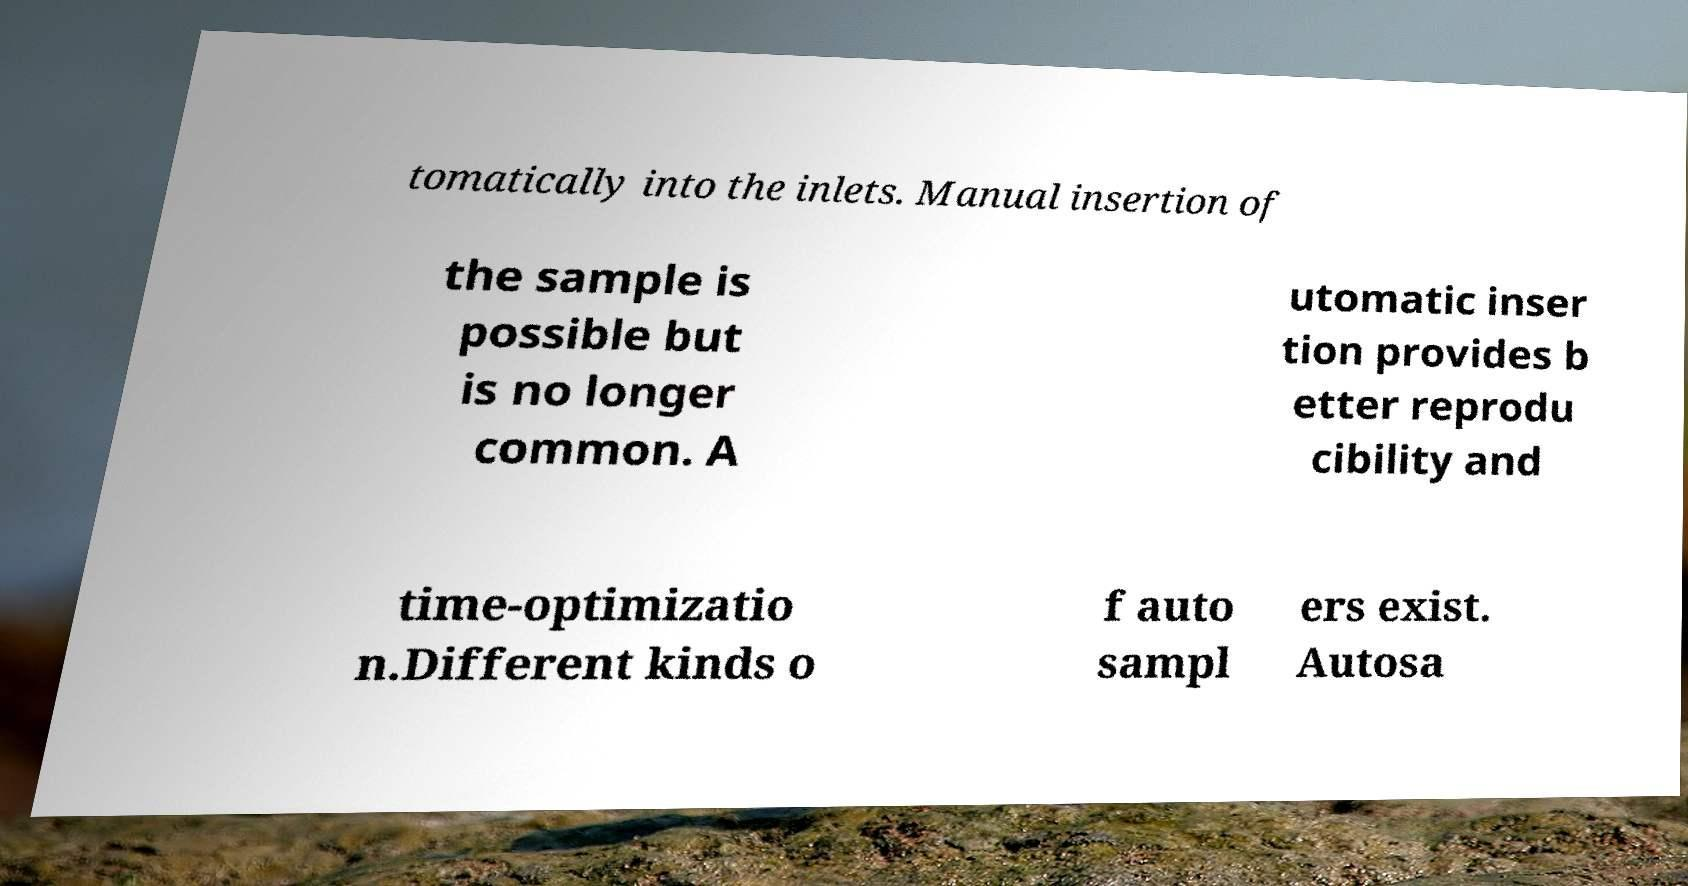Can you accurately transcribe the text from the provided image for me? tomatically into the inlets. Manual insertion of the sample is possible but is no longer common. A utomatic inser tion provides b etter reprodu cibility and time-optimizatio n.Different kinds o f auto sampl ers exist. Autosa 